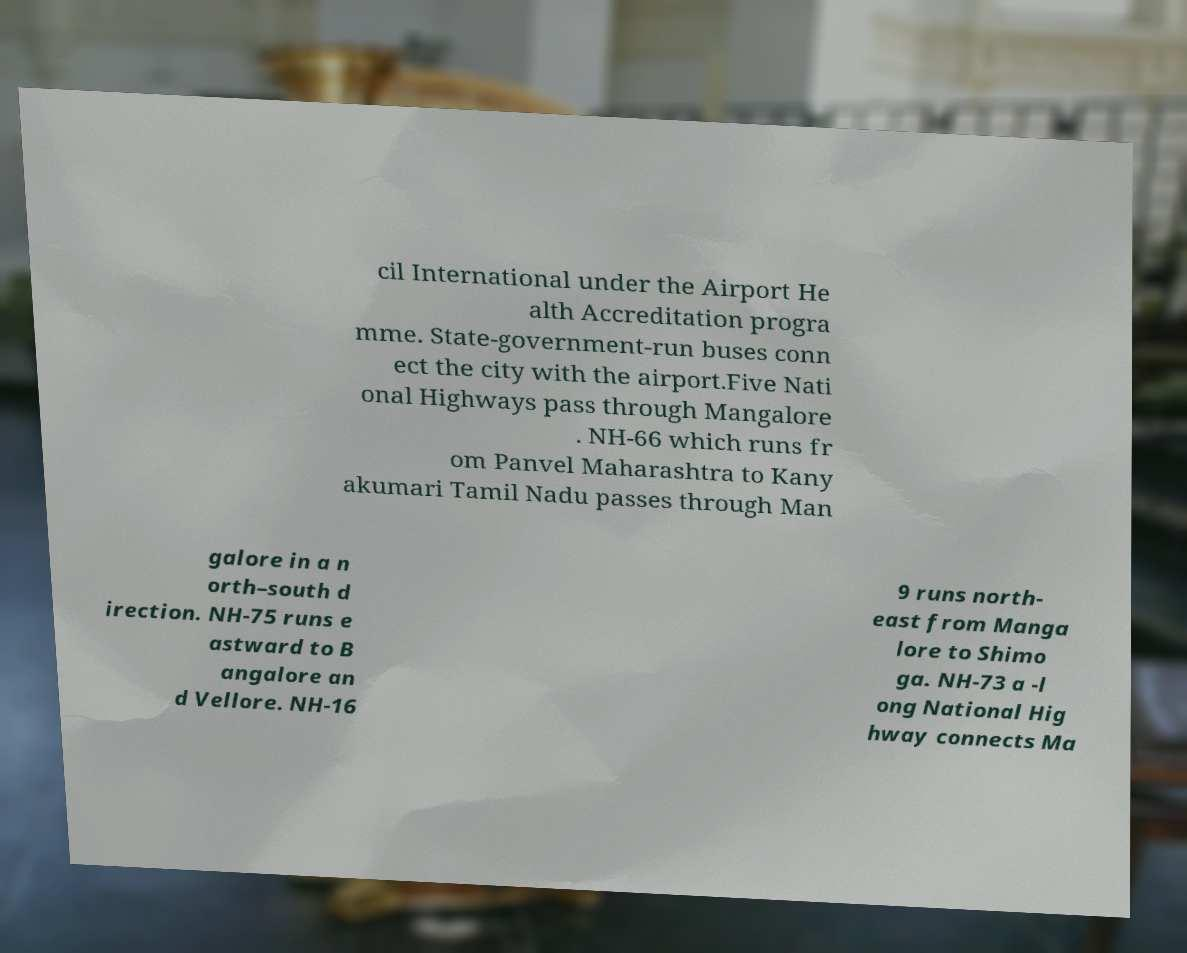Could you assist in decoding the text presented in this image and type it out clearly? cil International under the Airport He alth Accreditation progra mme. State-government-run buses conn ect the city with the airport.Five Nati onal Highways pass through Mangalore . NH-66 which runs fr om Panvel Maharashtra to Kany akumari Tamil Nadu passes through Man galore in a n orth–south d irection. NH-75 runs e astward to B angalore an d Vellore. NH-16 9 runs north- east from Manga lore to Shimo ga. NH-73 a -l ong National Hig hway connects Ma 